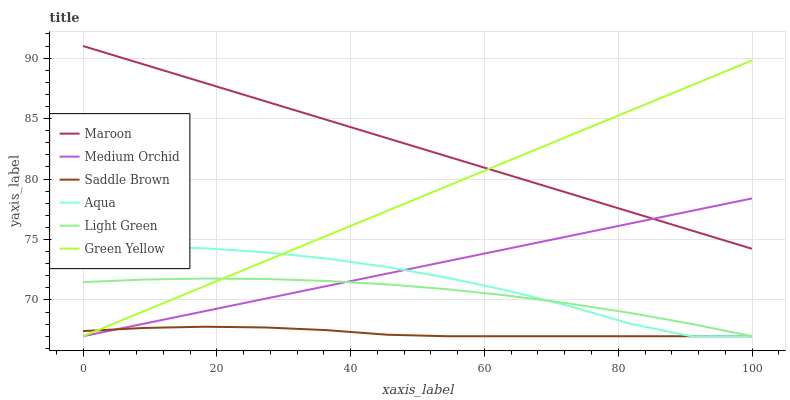Does Saddle Brown have the minimum area under the curve?
Answer yes or no. Yes. Does Maroon have the maximum area under the curve?
Answer yes or no. Yes. Does Aqua have the minimum area under the curve?
Answer yes or no. No. Does Aqua have the maximum area under the curve?
Answer yes or no. No. Is Green Yellow the smoothest?
Answer yes or no. Yes. Is Aqua the roughest?
Answer yes or no. Yes. Is Maroon the smoothest?
Answer yes or no. No. Is Maroon the roughest?
Answer yes or no. No. Does Medium Orchid have the lowest value?
Answer yes or no. Yes. Does Maroon have the lowest value?
Answer yes or no. No. Does Maroon have the highest value?
Answer yes or no. Yes. Does Aqua have the highest value?
Answer yes or no. No. Is Light Green less than Maroon?
Answer yes or no. Yes. Is Maroon greater than Light Green?
Answer yes or no. Yes. Does Saddle Brown intersect Medium Orchid?
Answer yes or no. Yes. Is Saddle Brown less than Medium Orchid?
Answer yes or no. No. Is Saddle Brown greater than Medium Orchid?
Answer yes or no. No. Does Light Green intersect Maroon?
Answer yes or no. No. 